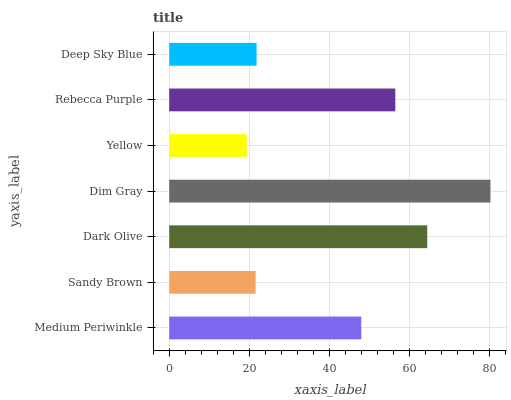Is Yellow the minimum?
Answer yes or no. Yes. Is Dim Gray the maximum?
Answer yes or no. Yes. Is Sandy Brown the minimum?
Answer yes or no. No. Is Sandy Brown the maximum?
Answer yes or no. No. Is Medium Periwinkle greater than Sandy Brown?
Answer yes or no. Yes. Is Sandy Brown less than Medium Periwinkle?
Answer yes or no. Yes. Is Sandy Brown greater than Medium Periwinkle?
Answer yes or no. No. Is Medium Periwinkle less than Sandy Brown?
Answer yes or no. No. Is Medium Periwinkle the high median?
Answer yes or no. Yes. Is Medium Periwinkle the low median?
Answer yes or no. Yes. Is Rebecca Purple the high median?
Answer yes or no. No. Is Rebecca Purple the low median?
Answer yes or no. No. 